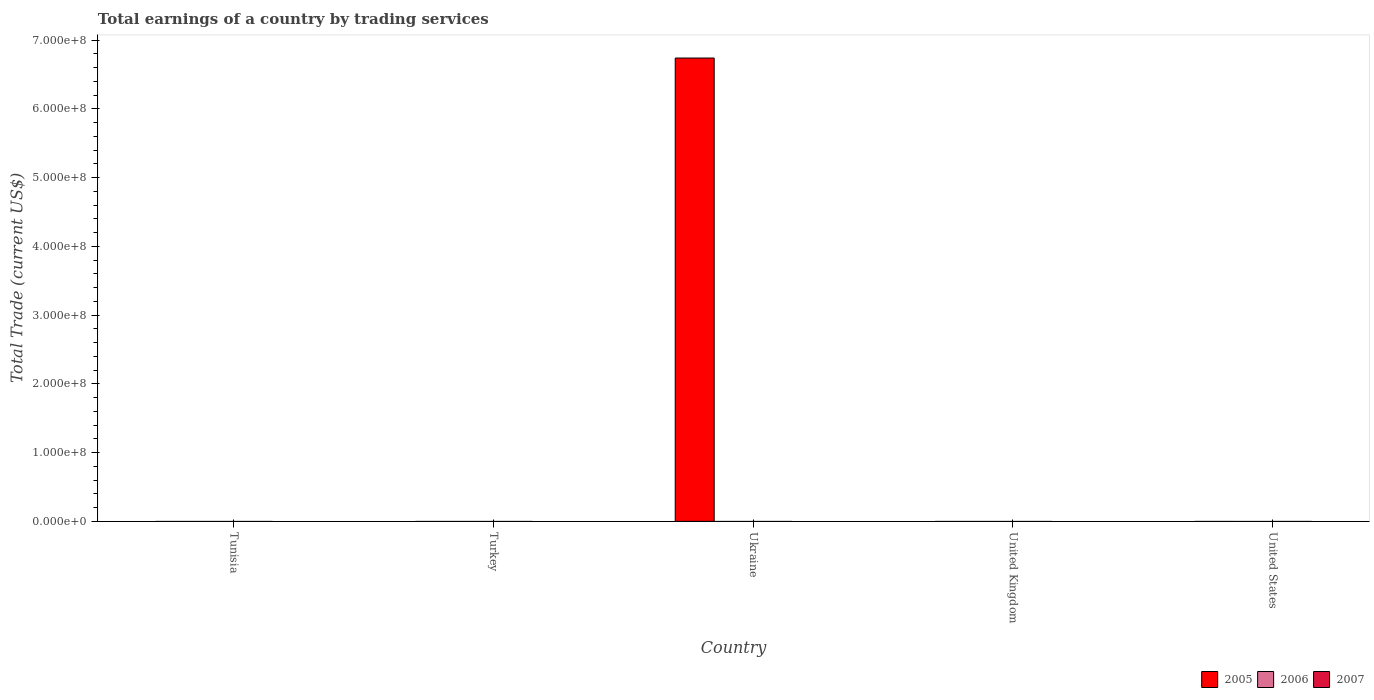How many bars are there on the 1st tick from the right?
Offer a terse response. 0. What is the label of the 1st group of bars from the left?
Provide a short and direct response. Tunisia. In how many cases, is the number of bars for a given country not equal to the number of legend labels?
Give a very brief answer. 5. What is the total earnings in 2006 in Ukraine?
Your response must be concise. 0. Across all countries, what is the maximum total earnings in 2005?
Offer a very short reply. 6.74e+08. Across all countries, what is the minimum total earnings in 2007?
Your answer should be very brief. 0. In which country was the total earnings in 2005 maximum?
Offer a terse response. Ukraine. What is the total total earnings in 2005 in the graph?
Keep it short and to the point. 6.74e+08. In how many countries, is the total earnings in 2006 greater than 160000000 US$?
Offer a terse response. 0. What is the difference between the highest and the lowest total earnings in 2005?
Keep it short and to the point. 6.74e+08. Is it the case that in every country, the sum of the total earnings in 2005 and total earnings in 2007 is greater than the total earnings in 2006?
Your answer should be very brief. No. Are the values on the major ticks of Y-axis written in scientific E-notation?
Your answer should be very brief. Yes. Does the graph contain grids?
Ensure brevity in your answer.  No. How many legend labels are there?
Give a very brief answer. 3. How are the legend labels stacked?
Your answer should be very brief. Horizontal. What is the title of the graph?
Provide a short and direct response. Total earnings of a country by trading services. Does "1960" appear as one of the legend labels in the graph?
Provide a short and direct response. No. What is the label or title of the Y-axis?
Provide a succinct answer. Total Trade (current US$). What is the Total Trade (current US$) in 2005 in Tunisia?
Keep it short and to the point. 0. What is the Total Trade (current US$) in 2006 in Tunisia?
Keep it short and to the point. 0. What is the Total Trade (current US$) of 2007 in Tunisia?
Your response must be concise. 0. What is the Total Trade (current US$) in 2005 in Turkey?
Offer a terse response. 0. What is the Total Trade (current US$) of 2007 in Turkey?
Make the answer very short. 0. What is the Total Trade (current US$) in 2005 in Ukraine?
Provide a succinct answer. 6.74e+08. What is the Total Trade (current US$) of 2007 in Ukraine?
Offer a terse response. 0. What is the Total Trade (current US$) in 2007 in United Kingdom?
Provide a succinct answer. 0. What is the Total Trade (current US$) of 2005 in United States?
Your answer should be very brief. 0. Across all countries, what is the maximum Total Trade (current US$) of 2005?
Provide a succinct answer. 6.74e+08. Across all countries, what is the minimum Total Trade (current US$) in 2005?
Ensure brevity in your answer.  0. What is the total Total Trade (current US$) in 2005 in the graph?
Ensure brevity in your answer.  6.74e+08. What is the total Total Trade (current US$) in 2007 in the graph?
Give a very brief answer. 0. What is the average Total Trade (current US$) of 2005 per country?
Give a very brief answer. 1.35e+08. What is the average Total Trade (current US$) of 2007 per country?
Your response must be concise. 0. What is the difference between the highest and the lowest Total Trade (current US$) of 2005?
Your answer should be compact. 6.74e+08. 